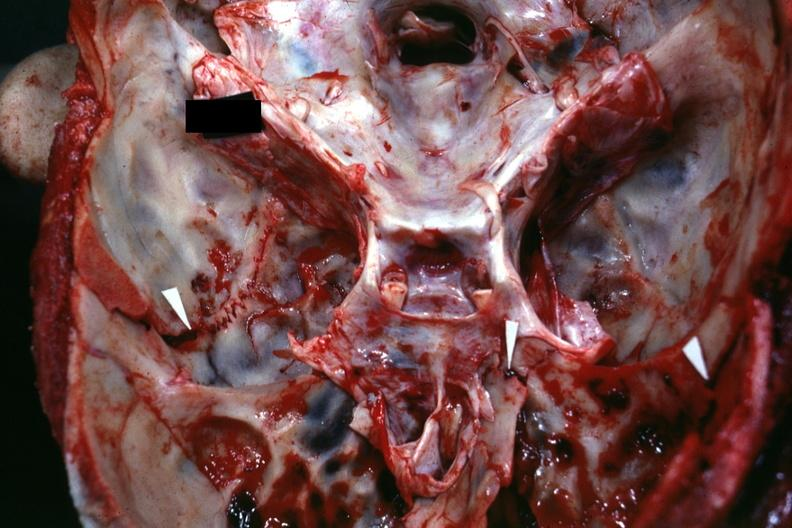what is present?
Answer the question using a single word or phrase. Bone 